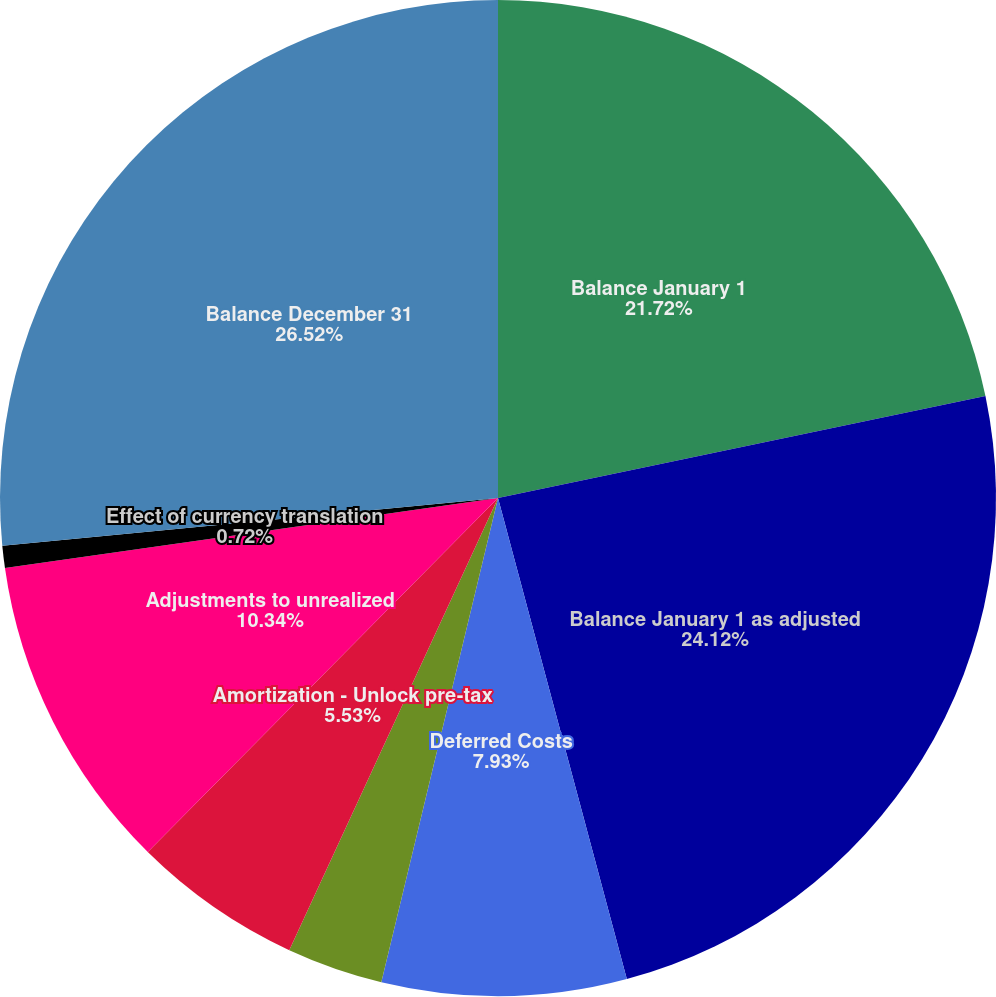<chart> <loc_0><loc_0><loc_500><loc_500><pie_chart><fcel>Balance January 1<fcel>Balance January 1 as adjusted<fcel>Deferred Costs<fcel>Amortization - Deferred policy<fcel>Amortization - Unlock pre-tax<fcel>Adjustments to unrealized<fcel>Effect of currency translation<fcel>Balance December 31<nl><fcel>21.72%<fcel>24.12%<fcel>7.93%<fcel>3.12%<fcel>5.53%<fcel>10.34%<fcel>0.72%<fcel>26.53%<nl></chart> 